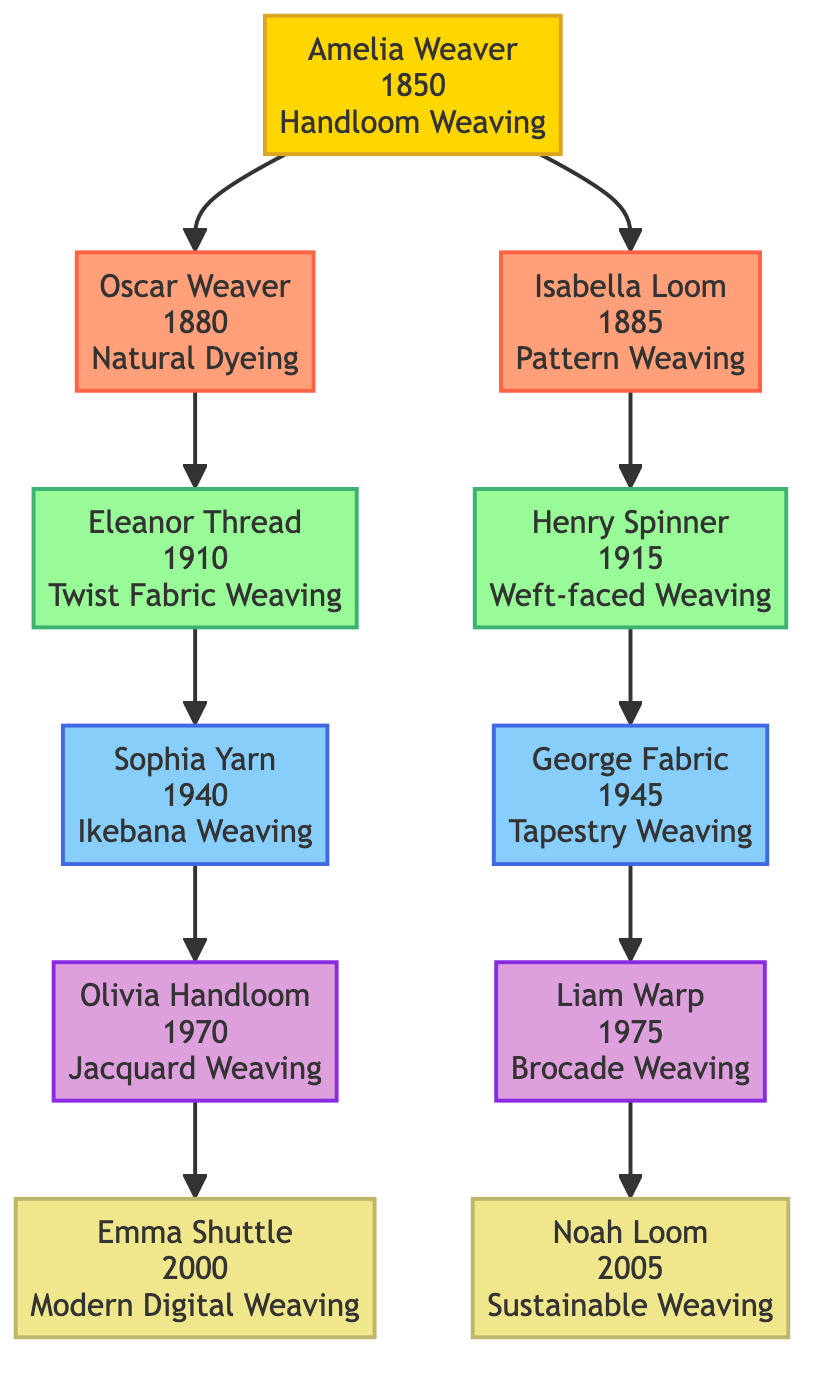What is the birth year of Oscar Weaver? Oscar Weaver is shown as one of the members in the second generation of the family tree. The diagram includes the birth year "1880" next to his name. Thus, his birth year is directly read from the node.
Answer: 1880 Who is the founder of the weaving lineage? The lineage starts with the "Founder" node, which identifies Amelia Weaver as the founder. This is clear as her name is prominently displayed in a distinct node labeled "Founder."
Answer: Amelia Weaver How many members are in the fourth generation? The fourth generation, indicated by the respective node, contains two members: Sophia Yarn and George Fabric. Counting these members gives us the total in the fourth generation.
Answer: 2 Which weaving technique is associated with Eleanor Thread? Eleanor Thread is listed as a member of the third generation, and her specific technique is mentioned in her node as "Twist Fabric Weaving." This information is directly available in the diagram.
Answer: Twist Fabric Weaving Who directly follows Henry Spinner in the lineage? The diagram shows that from Henry Spinner, the lineage continues to the fourth generation members Sophia Yarn and George Fabric. The relationship shows that Henry Spinner is the last member leading to the next generation, thus the next members are Sophia and George.
Answer: Sophia Yarn, George Fabric What technique does the founder use? Amelia Weaver, as the founder, has "Handloom Weaving" noted next to her name. This information can be found within her node in the diagram.
Answer: Handloom Weaving Which generation does Liam Warp belong to? The diagram indicates Liam Warp is a member of the fifth generation. This can be identified by locating his node and noting the generation label associated with it.
Answer: Fifth What is the birth year difference between Sophia Yarn and Noah Loom? Sophia Yarn was born in 1940 and Noah Loom in 2005. To find the difference subtract 1940 from 2005, resulting in 65 years difference.
Answer: 65 Which member was born in 2000? The node for the sixth generation lists Emma Shuttle, who has "2000" next to her name, indicating her birth year. This information can be found directly in her node.
Answer: Emma Shuttle 